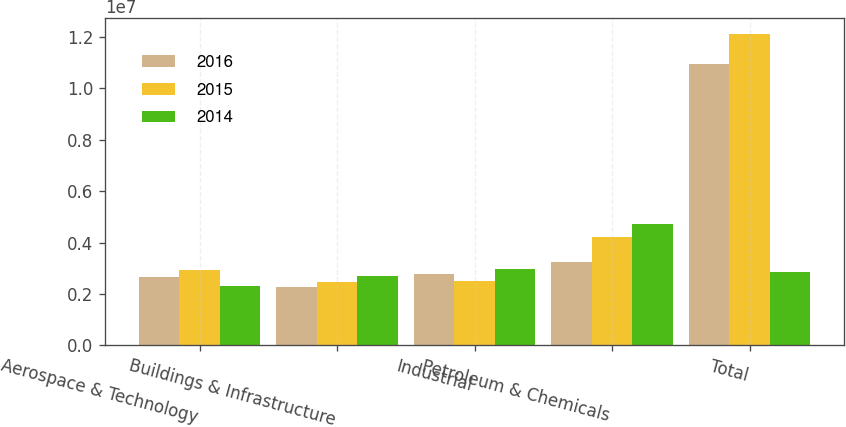Convert chart to OTSL. <chart><loc_0><loc_0><loc_500><loc_500><stacked_bar_chart><ecel><fcel>Aerospace & Technology<fcel>Buildings & Infrastructure<fcel>Industrial<fcel>Petroleum & Chemicals<fcel>Total<nl><fcel>2016<fcel>2.65743e+06<fcel>2.25351e+06<fcel>2.79371e+06<fcel>3.2595e+06<fcel>1.09642e+07<nl><fcel>2015<fcel>2.92475e+06<fcel>2.45838e+06<fcel>2.51757e+06<fcel>4.21413e+06<fcel>1.21148e+07<nl><fcel>2014<fcel>2.30645e+06<fcel>2.7052e+06<fcel>2.95639e+06<fcel>4.72712e+06<fcel>2.85923e+06<nl></chart> 